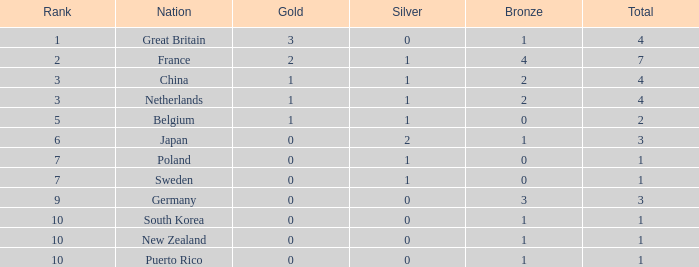What position has 0 bronze medals? None. 